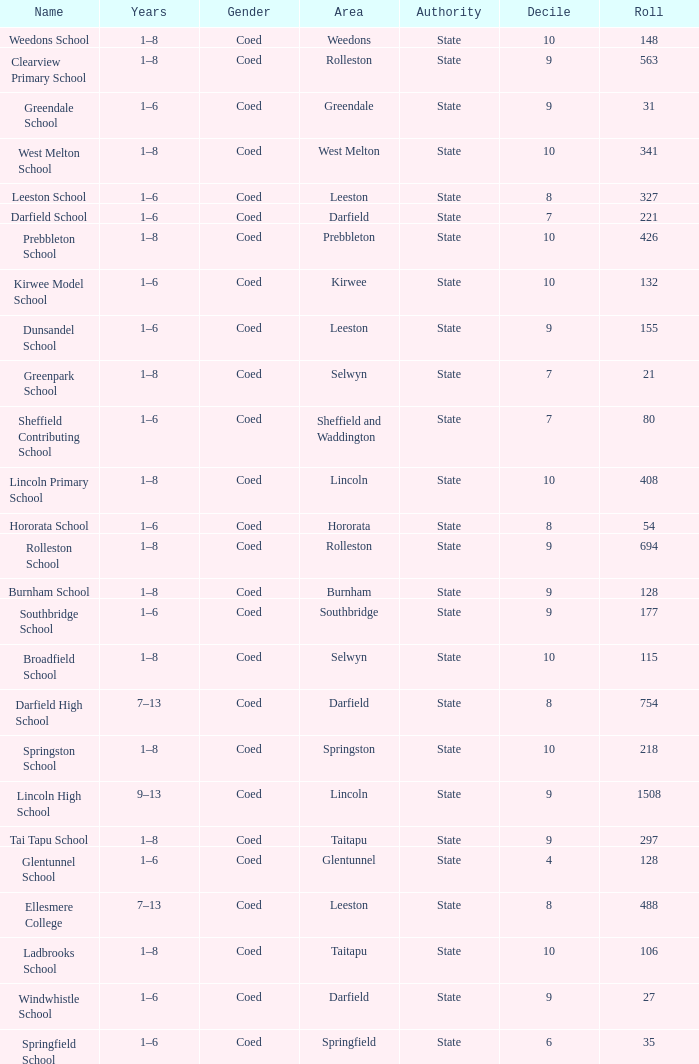Which area has a Decile of 9, and a Roll of 31? Greendale. 